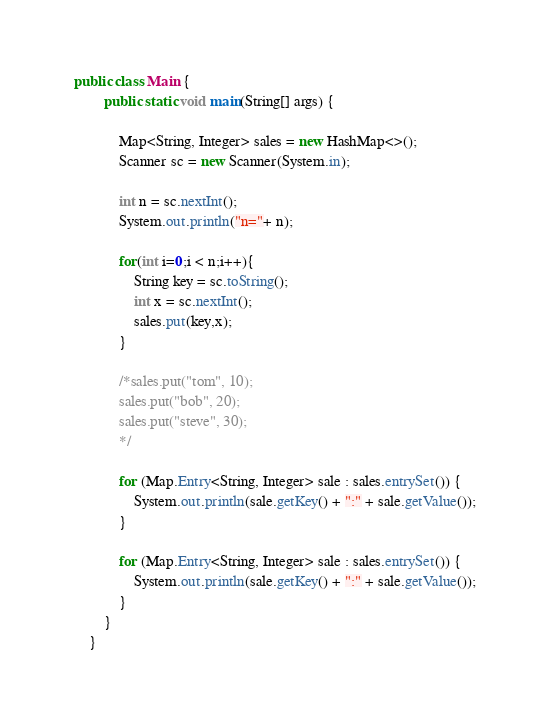<code> <loc_0><loc_0><loc_500><loc_500><_Java_>public class Main {
		public static void main(String[] args) {

			Map<String, Integer> sales = new HashMap<>();
			Scanner sc = new Scanner(System.in);

			int n = sc.nextInt();
			System.out.println("n="+ n);

			for(int i=0;i < n;i++){
				String key = sc.toString();
				int x = sc.nextInt();
				sales.put(key,x);
			}

			/*sales.put("tom", 10);
			sales.put("bob", 20);
			sales.put("steve", 30);
			*/

			for (Map.Entry<String, Integer> sale : sales.entrySet()) {
				System.out.println(sale.getKey() + ":" + sale.getValue());
			}

			for (Map.Entry<String, Integer> sale : sales.entrySet()) {
				System.out.println(sale.getKey() + ":" + sale.getValue());
			}
		}
	}
</code> 